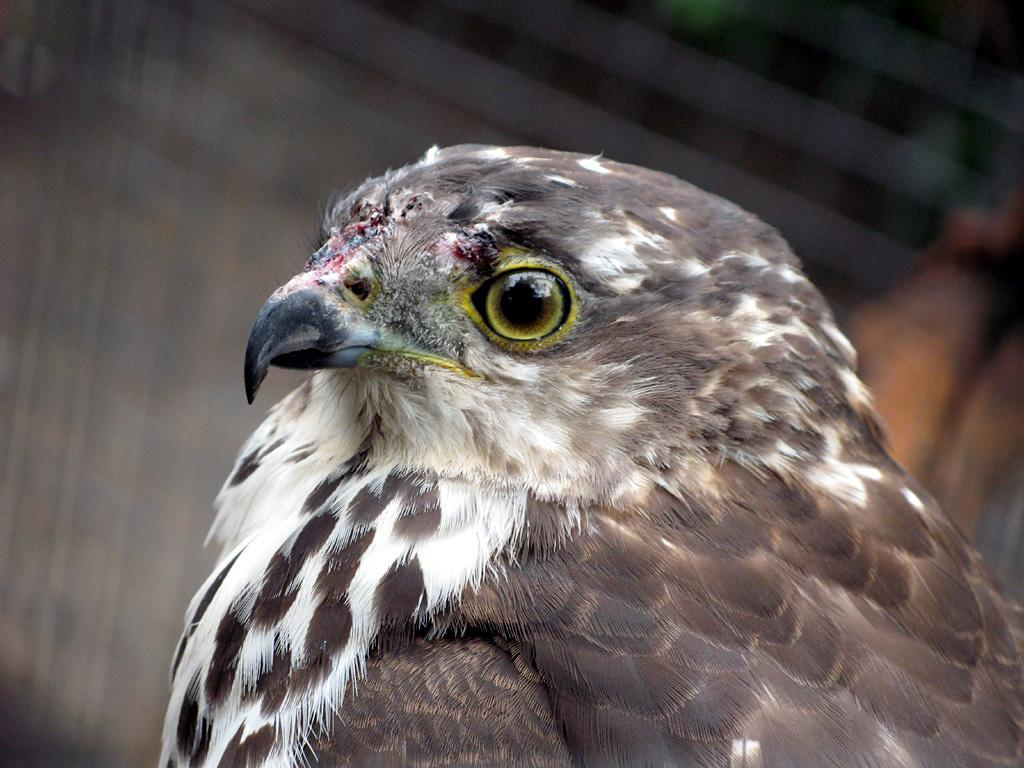What is the main subject of the image? There is a bird in the center of the image. Can you describe the bird in the image? Unfortunately, the image does not provide enough detail to describe the bird. What is the bird's position in the image? The bird is in the center of the image. How does the bird cry for help in the image? There is no indication in the image that the bird is crying for help, and birds do not have the ability to cry for help in the same way humans do. 